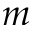<formula> <loc_0><loc_0><loc_500><loc_500>m</formula> 